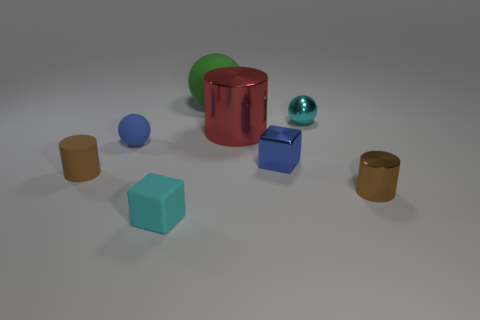Subtract all big green matte balls. How many balls are left? 2 Subtract all blocks. How many objects are left? 6 Add 2 brown matte things. How many objects exist? 10 Subtract all cyan blocks. How many blocks are left? 1 Subtract 2 cylinders. How many cylinders are left? 1 Subtract all cyan cylinders. How many green spheres are left? 1 Subtract all tiny rubber blocks. Subtract all blue metallic cubes. How many objects are left? 6 Add 2 blocks. How many blocks are left? 4 Add 5 cyan spheres. How many cyan spheres exist? 6 Subtract 1 cyan cubes. How many objects are left? 7 